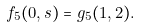<formula> <loc_0><loc_0><loc_500><loc_500>f _ { 5 } ( 0 , s ) = g _ { 5 } ( 1 , 2 ) .</formula> 